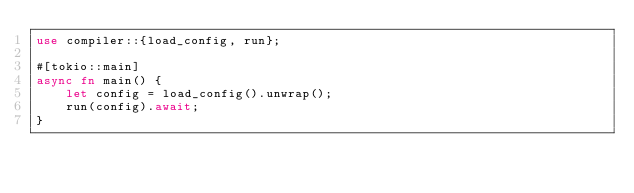Convert code to text. <code><loc_0><loc_0><loc_500><loc_500><_Rust_>use compiler::{load_config, run};

#[tokio::main]
async fn main() {
    let config = load_config().unwrap();
    run(config).await;
}
</code> 